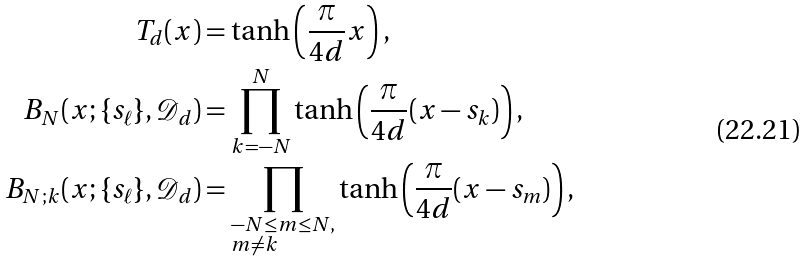<formula> <loc_0><loc_0><loc_500><loc_500>T _ { d } ( x ) & = \tanh \left ( \frac { \pi } { 4 d } x \right ) , \\ B _ { N } ( x ; \{ s _ { \ell } \} , \mathcal { D } _ { d } ) & = \prod _ { k = - N } ^ { N } \tanh \left ( \frac { \pi } { 4 d } ( x - s _ { k } ) \right ) , \\ B _ { N ; k } ( x ; \{ s _ { \ell } \} , \mathcal { D } _ { d } ) & = \prod _ { \begin{subarray} { c } - N \leq m \leq N , \\ m \neq k \end{subarray} } \tanh \left ( \frac { \pi } { 4 d } ( x - s _ { m } ) \right ) ,</formula> 